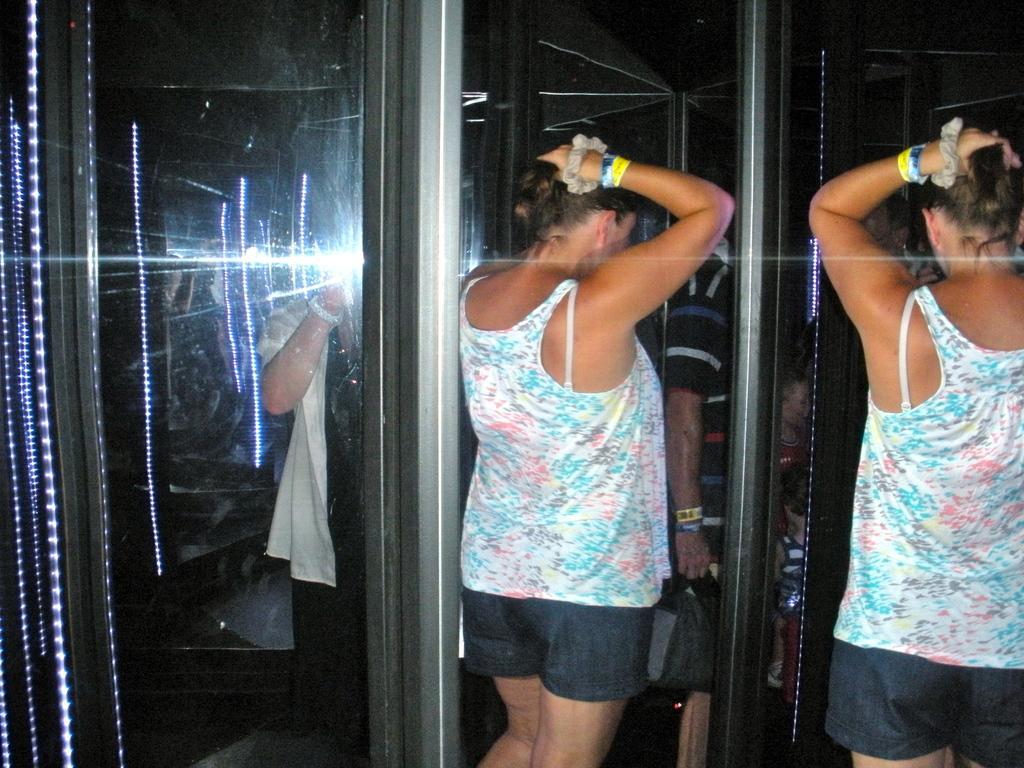Could you give a brief overview of what you see in this image? In the image there is a woman, she is tying her hair and beside the woman there are two mirrors and the image of the woman is being reflected in the first mirror and in the second mirror there is a person clicking the photo, the flashlight can be seen on the mirror. 